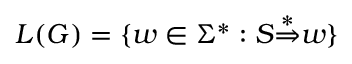Convert formula to latex. <formula><loc_0><loc_0><loc_500><loc_500>L ( G ) = \{ w \in \Sigma ^ { * } \colon S { \stackrel { * } { \Rightarrow } } w \}</formula> 